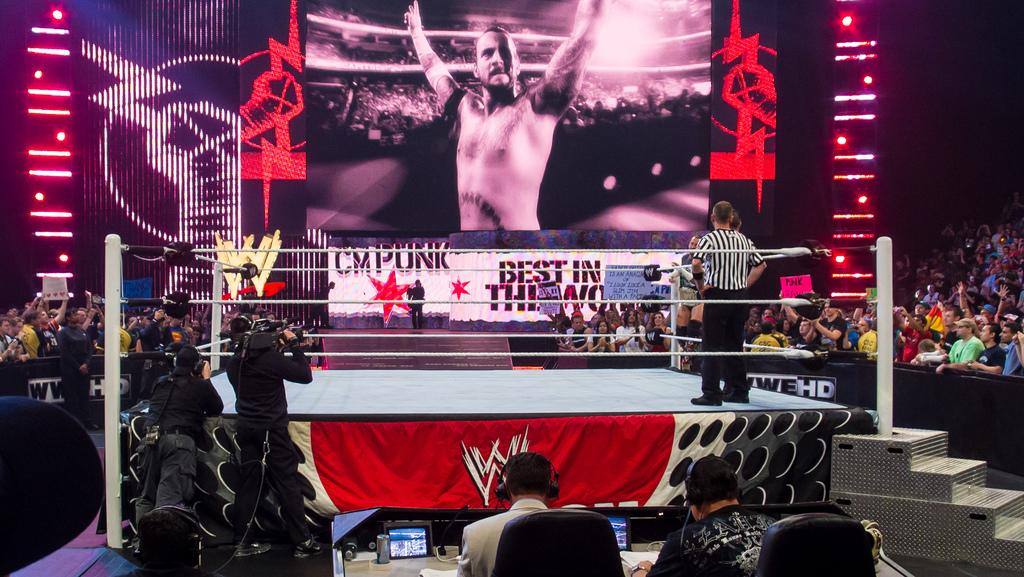Who or what can be seen in the image? There are people in the image. What is the main feature of the image? There is a boxing ring in the image. Are there any architectural features in the image? Yes, there are steps in the image. What type of equipment is present in the image? There are screens in the image. What type of seating is available in the image? There are chairs in the image. What type of lighting is present in the image? There are lights in the image. Are there any poles in the image? Yes, there are poles in the image. What type of decorations are present in the image? There are banners in the image. What type of knowledge is being shared in the image? There is no indication of knowledge being shared in the image; it features a boxing ring and related equipment. What type of haircut is being given to the person in the image? There is no person getting a haircut in the image; it features a boxing ring and related equipment. 